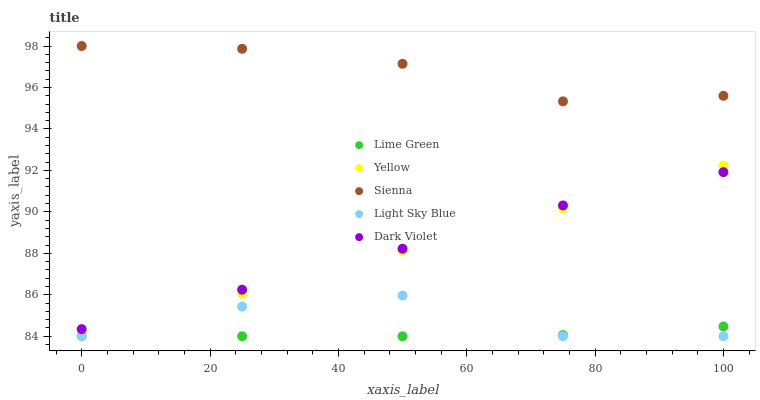Does Lime Green have the minimum area under the curve?
Answer yes or no. Yes. Does Sienna have the maximum area under the curve?
Answer yes or no. Yes. Does Light Sky Blue have the minimum area under the curve?
Answer yes or no. No. Does Light Sky Blue have the maximum area under the curve?
Answer yes or no. No. Is Yellow the smoothest?
Answer yes or no. Yes. Is Light Sky Blue the roughest?
Answer yes or no. Yes. Is Lime Green the smoothest?
Answer yes or no. No. Is Lime Green the roughest?
Answer yes or no. No. Does Light Sky Blue have the lowest value?
Answer yes or no. Yes. Does Dark Violet have the lowest value?
Answer yes or no. No. Does Sienna have the highest value?
Answer yes or no. Yes. Does Light Sky Blue have the highest value?
Answer yes or no. No. Is Light Sky Blue less than Dark Violet?
Answer yes or no. Yes. Is Sienna greater than Yellow?
Answer yes or no. Yes. Does Dark Violet intersect Yellow?
Answer yes or no. Yes. Is Dark Violet less than Yellow?
Answer yes or no. No. Is Dark Violet greater than Yellow?
Answer yes or no. No. Does Light Sky Blue intersect Dark Violet?
Answer yes or no. No. 